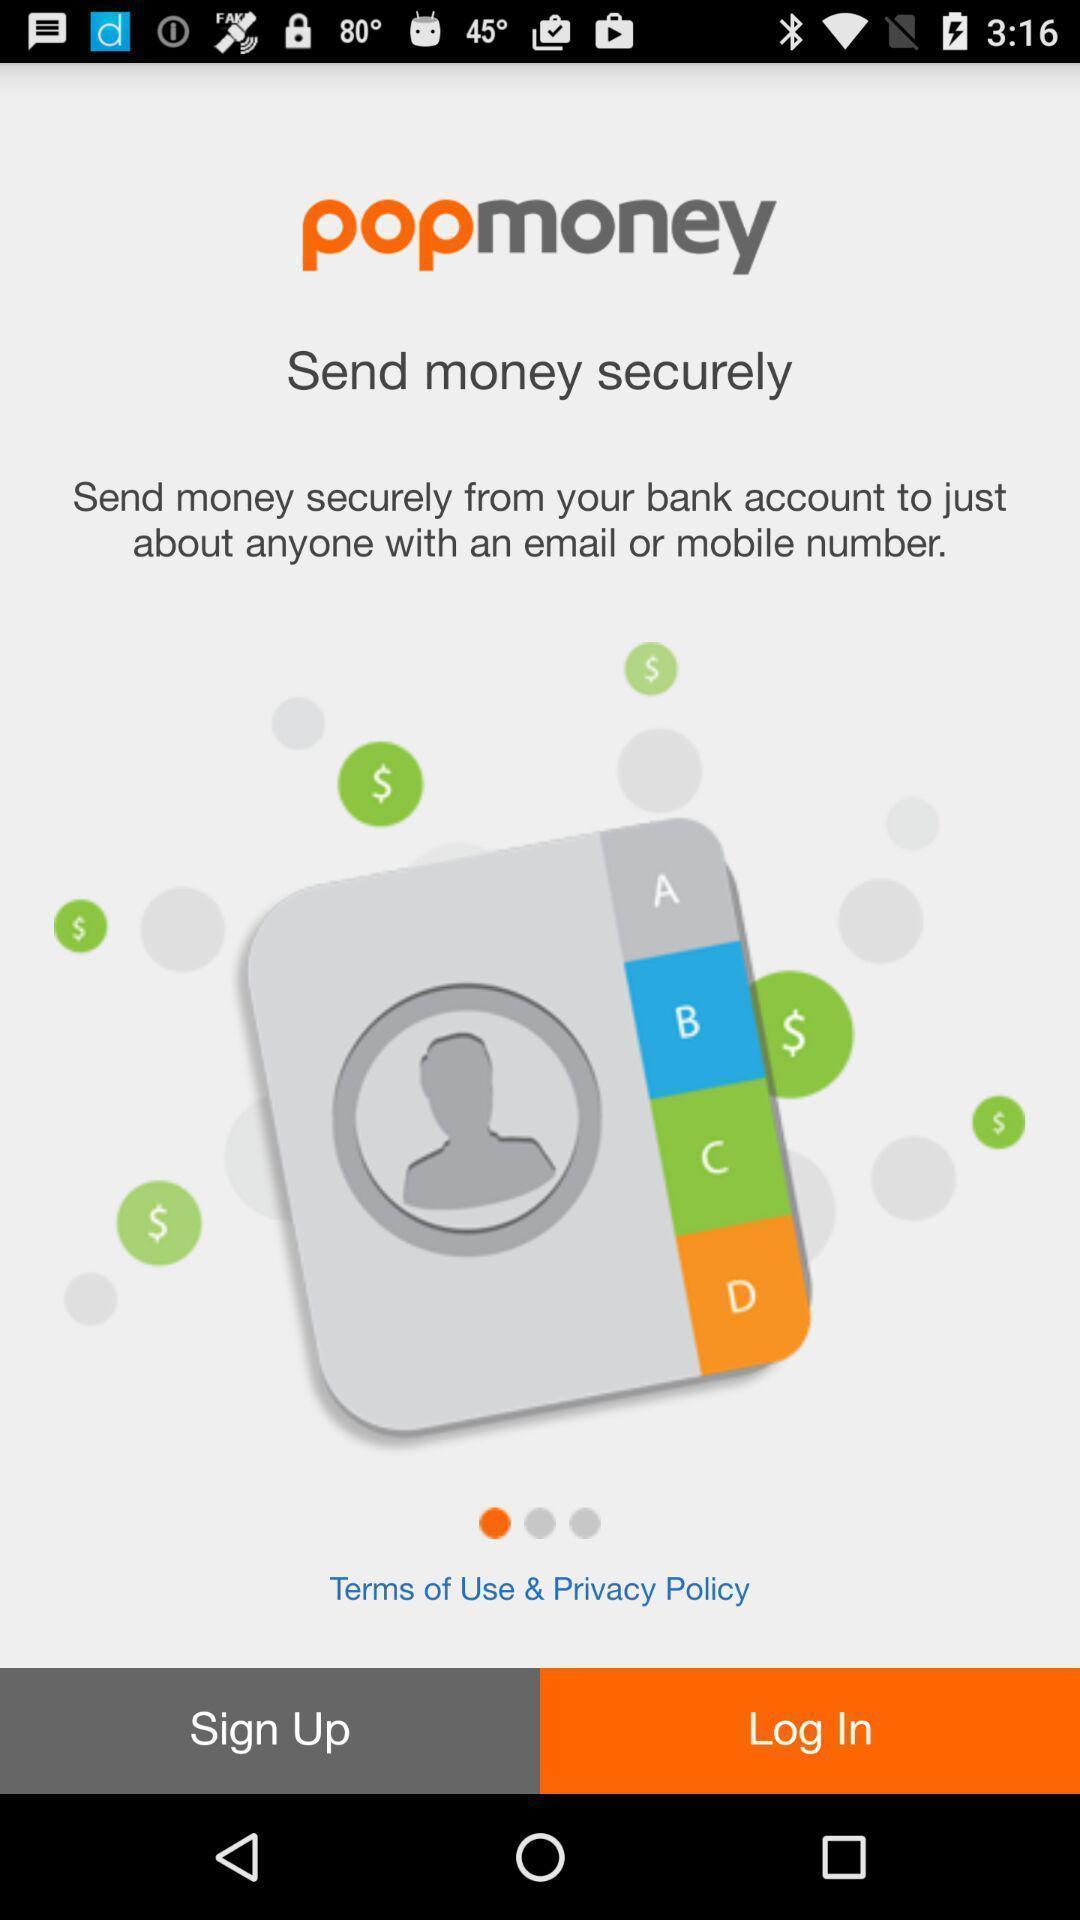Give me a narrative description of this picture. Sign in page displayed of an payment application. 